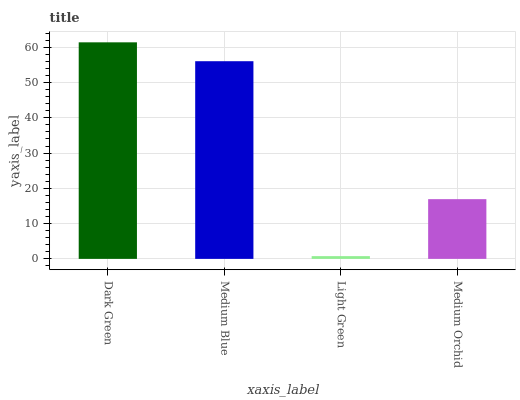Is Light Green the minimum?
Answer yes or no. Yes. Is Dark Green the maximum?
Answer yes or no. Yes. Is Medium Blue the minimum?
Answer yes or no. No. Is Medium Blue the maximum?
Answer yes or no. No. Is Dark Green greater than Medium Blue?
Answer yes or no. Yes. Is Medium Blue less than Dark Green?
Answer yes or no. Yes. Is Medium Blue greater than Dark Green?
Answer yes or no. No. Is Dark Green less than Medium Blue?
Answer yes or no. No. Is Medium Blue the high median?
Answer yes or no. Yes. Is Medium Orchid the low median?
Answer yes or no. Yes. Is Medium Orchid the high median?
Answer yes or no. No. Is Light Green the low median?
Answer yes or no. No. 